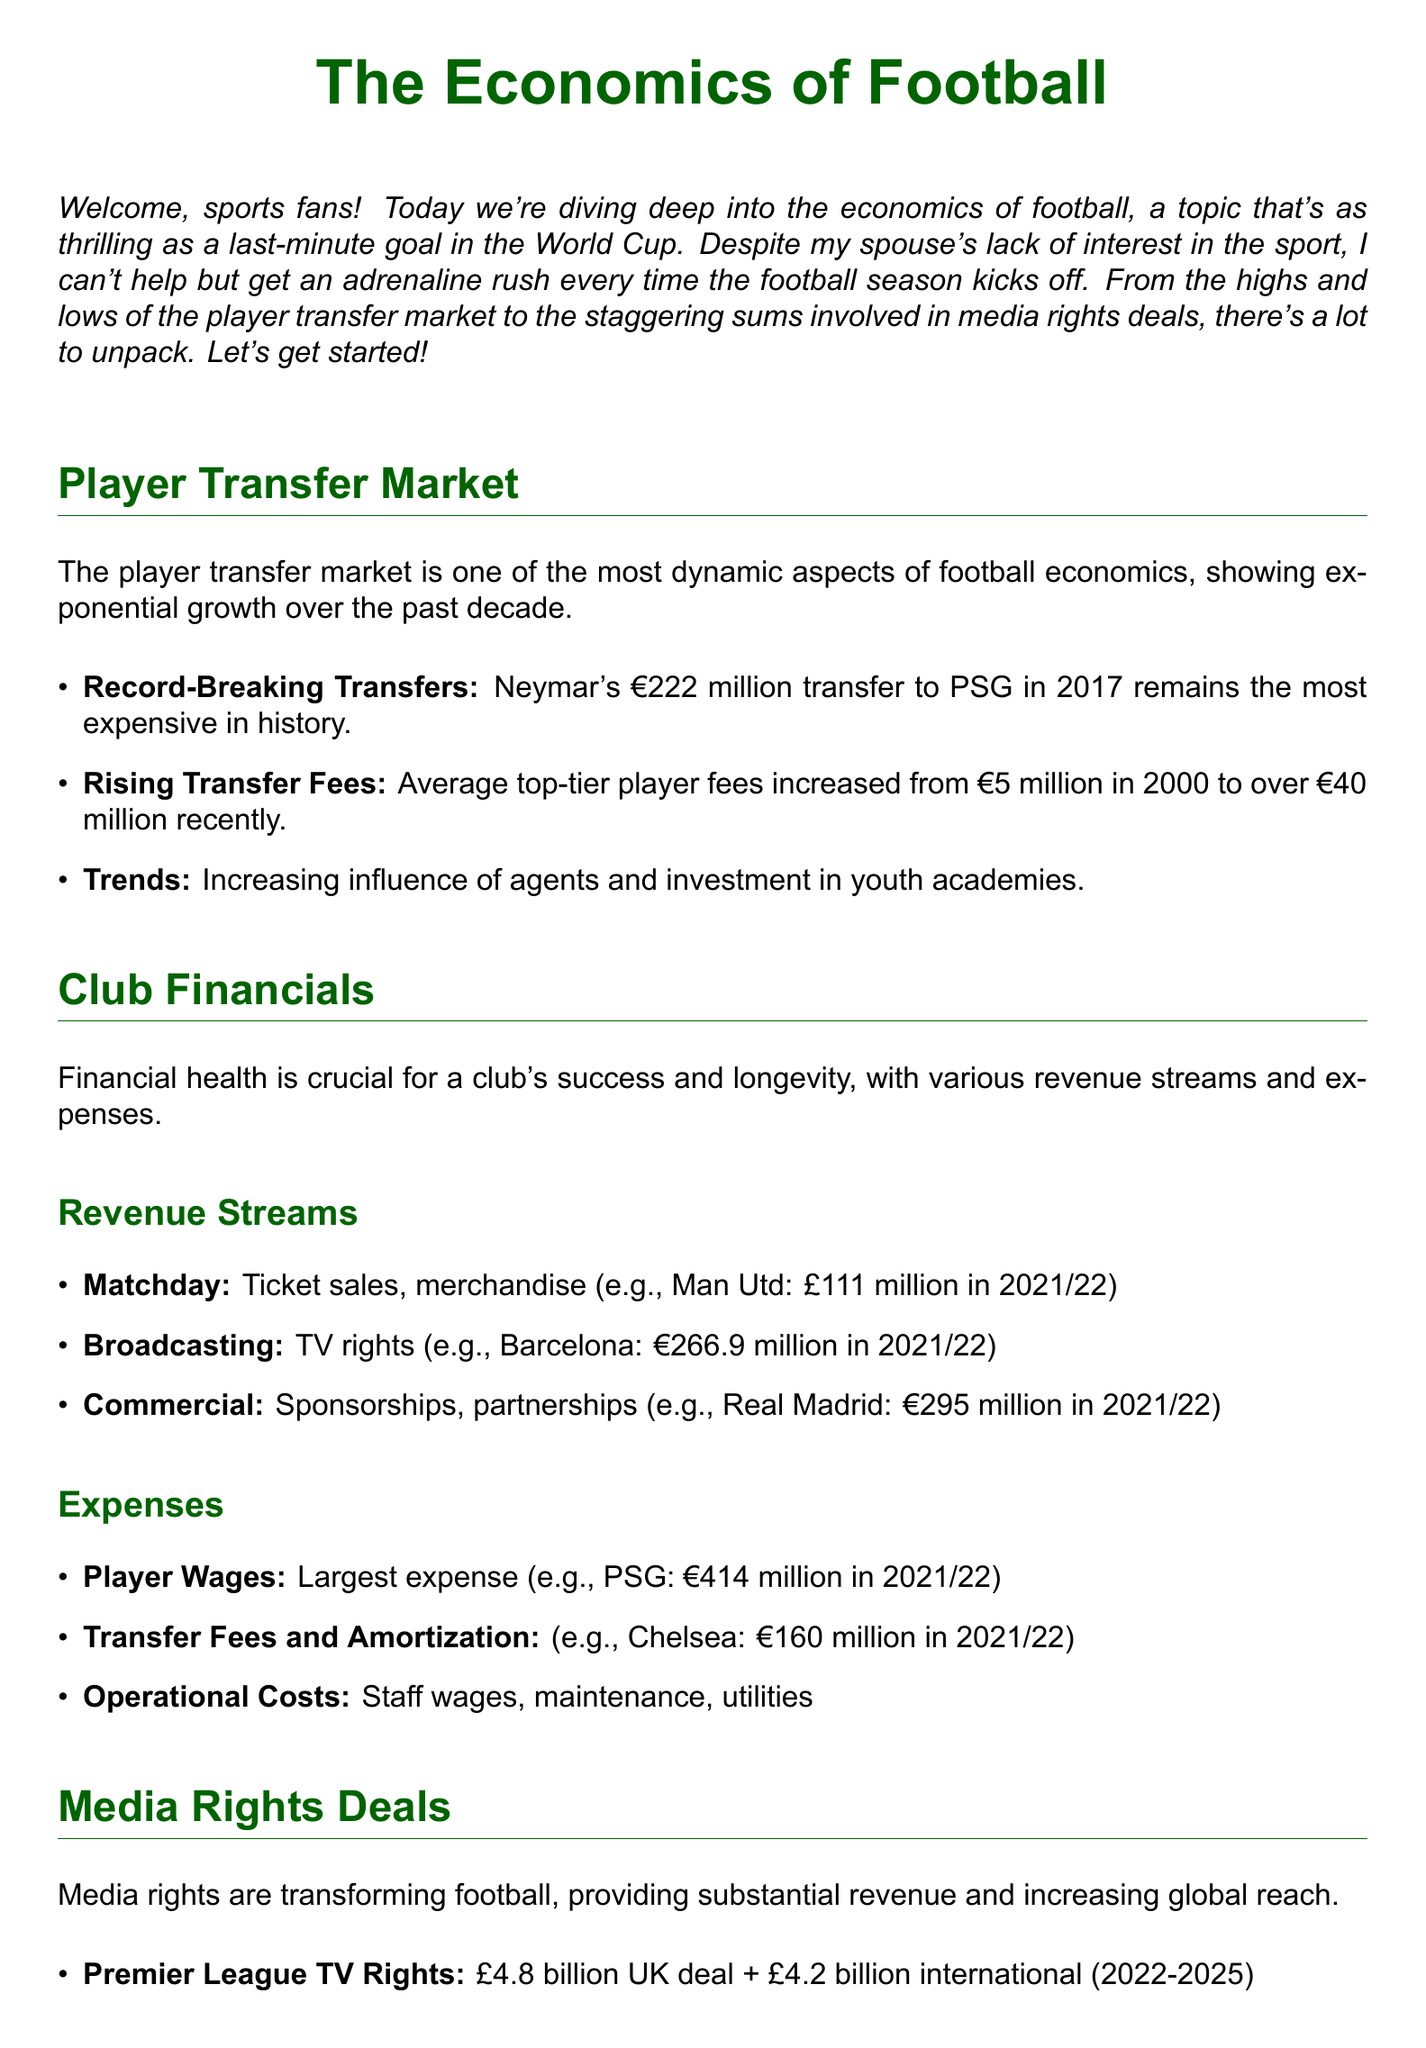what is the most expensive transfer in history? The document states that Neymar's transfer to PSG in 2017 for €222 million is the most expensive.
Answer: €222 million what were average top-tier player fees in 2000? The document indicates that average top-tier player fees were €5 million in 2000.
Answer: €5 million how much did Barcelona earn from broadcasting in 2021/22? According to the document, Barcelona earned €266.9 million from broadcasting in 2021/22.
Answer: €266.9 million what is PSG's player wage expense in 2021/22? The document mentions that PSG's player wage expense was €414 million in 2021/22.
Answer: €414 million what is the UK Premier League TV rights deal value for 2022-2025? The document states that the UK deal for Premier League TV rights is £4.8 billion for 2022-2025.
Answer: £4.8 billion how do media rights help smaller clubs? The document explains that media rights help smaller clubs compete financially.
Answer: Compete what is one trend in the player transfer market? The document notes the increasing influence of agents as a trend in the player transfer market.
Answer: Influence of agents what was Real Madrid's commercial revenue in 2021/22? The document states that Real Madrid's commercial revenue was €295 million in 2021/22.
Answer: €295 million what are the primary expenses for clubs mentioned in the document? The document identifies player wages, transfer fees, and operational costs as primary expenses.
Answer: Player wages, transfer fees, operational costs 